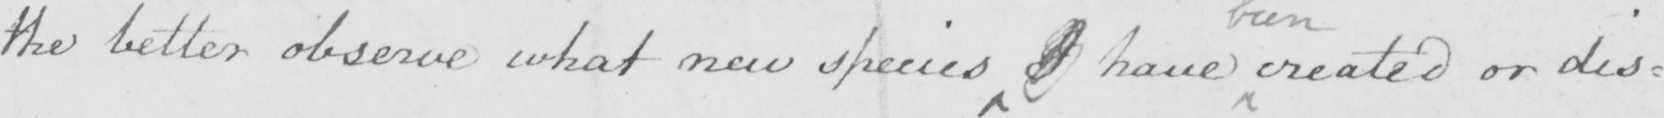What does this handwritten line say? the better observe what new species I have created or dis= 